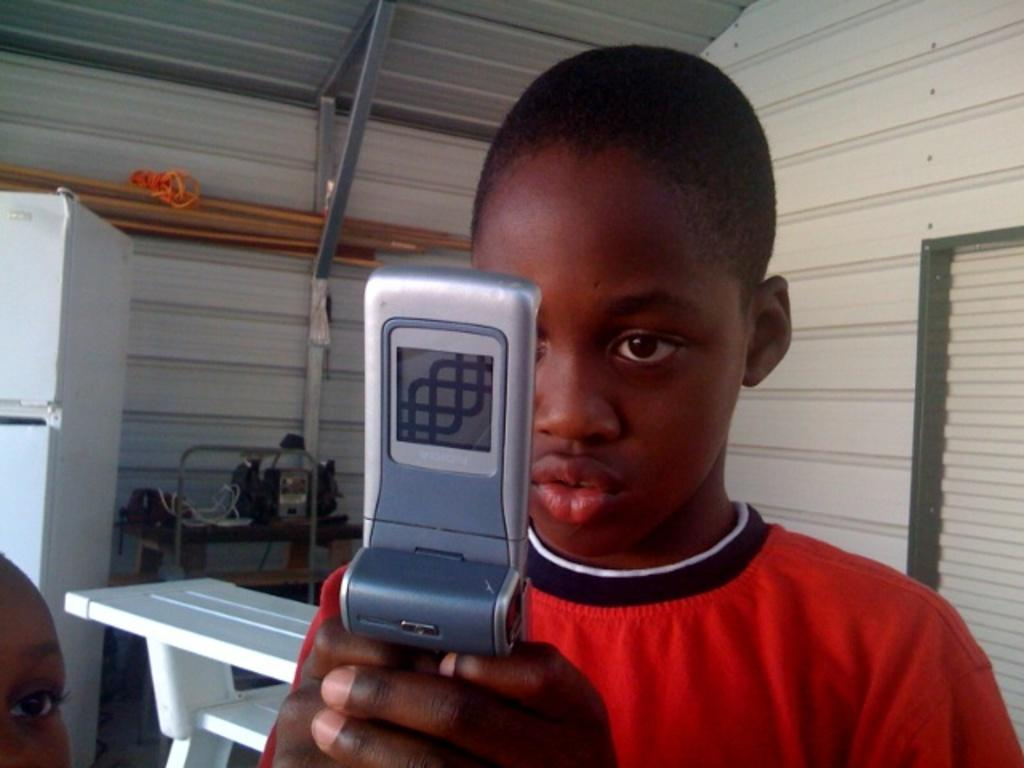What is the kid holding in the image? The kid is holding a mobile in the image. Who is beside the kid in the image? There is a person's face visible beside the kid. What can be seen in the background of the image? There is a table, a white object, a wall, and rods in the background of the image. What is on the table in the background of the image? There are objects on the table in the background of the image. How many beads are on the person's face in the image? There are no beads visible on the person's face in the image. What type of digestion can be observed in the image? There is no digestion process visible in the image. 